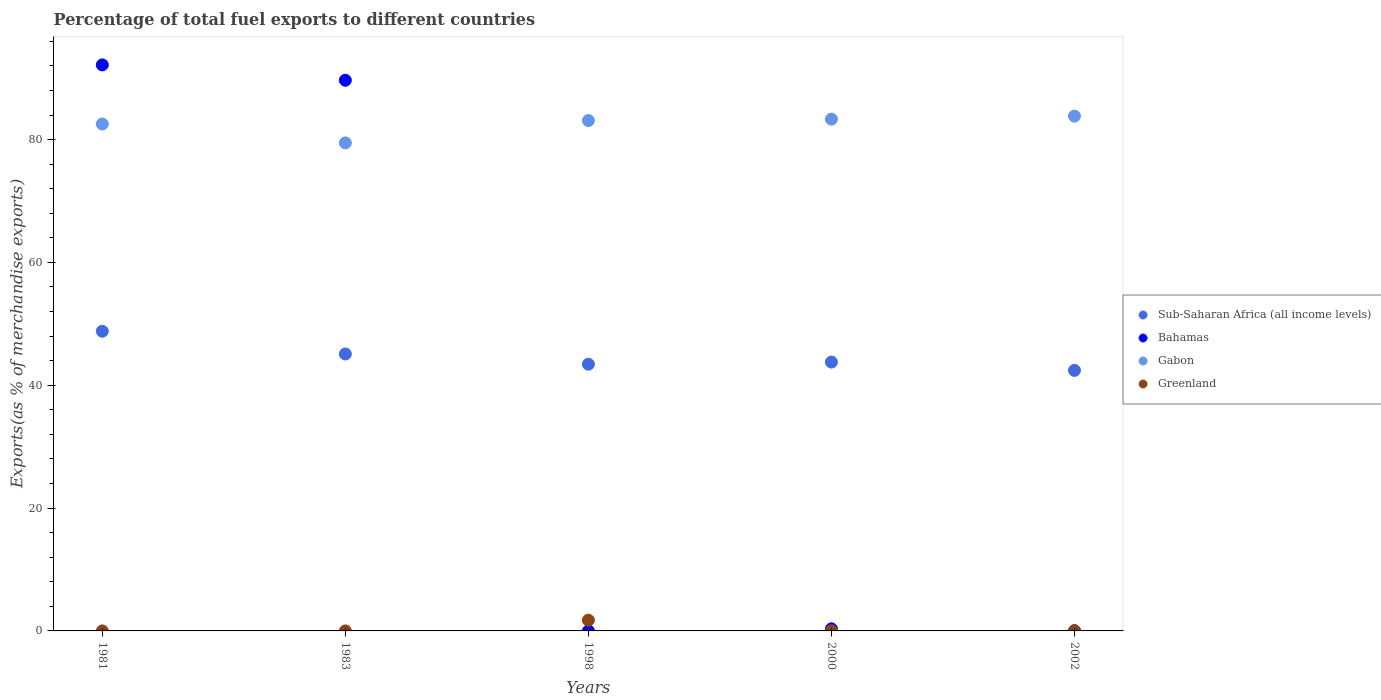Is the number of dotlines equal to the number of legend labels?
Your response must be concise. Yes. What is the percentage of exports to different countries in Sub-Saharan Africa (all income levels) in 1981?
Your answer should be very brief. 48.79. Across all years, what is the maximum percentage of exports to different countries in Bahamas?
Your answer should be very brief. 92.16. Across all years, what is the minimum percentage of exports to different countries in Greenland?
Provide a succinct answer. 1.891174772849889e-5. In which year was the percentage of exports to different countries in Bahamas maximum?
Offer a terse response. 1981. What is the total percentage of exports to different countries in Gabon in the graph?
Provide a short and direct response. 412.24. What is the difference between the percentage of exports to different countries in Sub-Saharan Africa (all income levels) in 1981 and that in 2002?
Offer a terse response. 6.37. What is the difference between the percentage of exports to different countries in Gabon in 2002 and the percentage of exports to different countries in Greenland in 2000?
Provide a succinct answer. 83.79. What is the average percentage of exports to different countries in Bahamas per year?
Provide a short and direct response. 36.44. In the year 2000, what is the difference between the percentage of exports to different countries in Greenland and percentage of exports to different countries in Bahamas?
Your answer should be very brief. -0.31. What is the ratio of the percentage of exports to different countries in Greenland in 1981 to that in 2002?
Offer a terse response. 0.01. What is the difference between the highest and the second highest percentage of exports to different countries in Gabon?
Provide a short and direct response. 0.49. What is the difference between the highest and the lowest percentage of exports to different countries in Gabon?
Offer a terse response. 4.35. Does the percentage of exports to different countries in Greenland monotonically increase over the years?
Provide a succinct answer. No. Is the percentage of exports to different countries in Gabon strictly greater than the percentage of exports to different countries in Greenland over the years?
Offer a very short reply. Yes. How many years are there in the graph?
Keep it short and to the point. 5. What is the difference between two consecutive major ticks on the Y-axis?
Make the answer very short. 20. Are the values on the major ticks of Y-axis written in scientific E-notation?
Provide a succinct answer. No. Does the graph contain grids?
Your answer should be very brief. No. Where does the legend appear in the graph?
Provide a succinct answer. Center right. How many legend labels are there?
Keep it short and to the point. 4. What is the title of the graph?
Offer a terse response. Percentage of total fuel exports to different countries. Does "Slovenia" appear as one of the legend labels in the graph?
Your response must be concise. No. What is the label or title of the Y-axis?
Your answer should be very brief. Exports(as % of merchandise exports). What is the Exports(as % of merchandise exports) of Sub-Saharan Africa (all income levels) in 1981?
Give a very brief answer. 48.79. What is the Exports(as % of merchandise exports) of Bahamas in 1981?
Your response must be concise. 92.16. What is the Exports(as % of merchandise exports) in Gabon in 1981?
Your answer should be compact. 82.53. What is the Exports(as % of merchandise exports) of Greenland in 1981?
Provide a succinct answer. 0. What is the Exports(as % of merchandise exports) in Sub-Saharan Africa (all income levels) in 1983?
Offer a very short reply. 45.09. What is the Exports(as % of merchandise exports) of Bahamas in 1983?
Your response must be concise. 89.66. What is the Exports(as % of merchandise exports) of Gabon in 1983?
Your answer should be very brief. 79.46. What is the Exports(as % of merchandise exports) in Greenland in 1983?
Keep it short and to the point. 1.891174772849889e-5. What is the Exports(as % of merchandise exports) in Sub-Saharan Africa (all income levels) in 1998?
Provide a short and direct response. 43.43. What is the Exports(as % of merchandise exports) in Bahamas in 1998?
Provide a short and direct response. 0. What is the Exports(as % of merchandise exports) of Gabon in 1998?
Your answer should be very brief. 83.1. What is the Exports(as % of merchandise exports) of Greenland in 1998?
Your answer should be compact. 1.75. What is the Exports(as % of merchandise exports) of Sub-Saharan Africa (all income levels) in 2000?
Provide a succinct answer. 43.77. What is the Exports(as % of merchandise exports) of Bahamas in 2000?
Make the answer very short. 0.34. What is the Exports(as % of merchandise exports) in Gabon in 2000?
Give a very brief answer. 83.33. What is the Exports(as % of merchandise exports) of Greenland in 2000?
Give a very brief answer. 0.03. What is the Exports(as % of merchandise exports) of Sub-Saharan Africa (all income levels) in 2002?
Ensure brevity in your answer.  42.42. What is the Exports(as % of merchandise exports) in Bahamas in 2002?
Ensure brevity in your answer.  0.03. What is the Exports(as % of merchandise exports) of Gabon in 2002?
Give a very brief answer. 83.82. What is the Exports(as % of merchandise exports) in Greenland in 2002?
Your answer should be compact. 0.02. Across all years, what is the maximum Exports(as % of merchandise exports) of Sub-Saharan Africa (all income levels)?
Offer a very short reply. 48.79. Across all years, what is the maximum Exports(as % of merchandise exports) of Bahamas?
Offer a terse response. 92.16. Across all years, what is the maximum Exports(as % of merchandise exports) in Gabon?
Your answer should be compact. 83.82. Across all years, what is the maximum Exports(as % of merchandise exports) of Greenland?
Your response must be concise. 1.75. Across all years, what is the minimum Exports(as % of merchandise exports) of Sub-Saharan Africa (all income levels)?
Provide a succinct answer. 42.42. Across all years, what is the minimum Exports(as % of merchandise exports) of Bahamas?
Offer a terse response. 0. Across all years, what is the minimum Exports(as % of merchandise exports) of Gabon?
Your answer should be very brief. 79.46. Across all years, what is the minimum Exports(as % of merchandise exports) of Greenland?
Your answer should be very brief. 1.891174772849889e-5. What is the total Exports(as % of merchandise exports) in Sub-Saharan Africa (all income levels) in the graph?
Ensure brevity in your answer.  223.51. What is the total Exports(as % of merchandise exports) in Bahamas in the graph?
Your response must be concise. 182.19. What is the total Exports(as % of merchandise exports) of Gabon in the graph?
Your answer should be compact. 412.24. What is the total Exports(as % of merchandise exports) in Greenland in the graph?
Provide a succinct answer. 1.8. What is the difference between the Exports(as % of merchandise exports) of Sub-Saharan Africa (all income levels) in 1981 and that in 1983?
Your response must be concise. 3.7. What is the difference between the Exports(as % of merchandise exports) of Bahamas in 1981 and that in 1983?
Your response must be concise. 2.5. What is the difference between the Exports(as % of merchandise exports) of Gabon in 1981 and that in 1983?
Offer a very short reply. 3.07. What is the difference between the Exports(as % of merchandise exports) of Sub-Saharan Africa (all income levels) in 1981 and that in 1998?
Offer a terse response. 5.36. What is the difference between the Exports(as % of merchandise exports) of Bahamas in 1981 and that in 1998?
Ensure brevity in your answer.  92.16. What is the difference between the Exports(as % of merchandise exports) in Gabon in 1981 and that in 1998?
Provide a succinct answer. -0.56. What is the difference between the Exports(as % of merchandise exports) of Greenland in 1981 and that in 1998?
Offer a very short reply. -1.75. What is the difference between the Exports(as % of merchandise exports) of Sub-Saharan Africa (all income levels) in 1981 and that in 2000?
Provide a short and direct response. 5.02. What is the difference between the Exports(as % of merchandise exports) in Bahamas in 1981 and that in 2000?
Your response must be concise. 91.82. What is the difference between the Exports(as % of merchandise exports) of Gabon in 1981 and that in 2000?
Ensure brevity in your answer.  -0.79. What is the difference between the Exports(as % of merchandise exports) of Greenland in 1981 and that in 2000?
Provide a succinct answer. -0.03. What is the difference between the Exports(as % of merchandise exports) in Sub-Saharan Africa (all income levels) in 1981 and that in 2002?
Your answer should be very brief. 6.37. What is the difference between the Exports(as % of merchandise exports) in Bahamas in 1981 and that in 2002?
Offer a terse response. 92.13. What is the difference between the Exports(as % of merchandise exports) in Gabon in 1981 and that in 2002?
Offer a very short reply. -1.28. What is the difference between the Exports(as % of merchandise exports) of Greenland in 1981 and that in 2002?
Make the answer very short. -0.02. What is the difference between the Exports(as % of merchandise exports) of Sub-Saharan Africa (all income levels) in 1983 and that in 1998?
Give a very brief answer. 1.66. What is the difference between the Exports(as % of merchandise exports) in Bahamas in 1983 and that in 1998?
Give a very brief answer. 89.66. What is the difference between the Exports(as % of merchandise exports) in Gabon in 1983 and that in 1998?
Your answer should be very brief. -3.63. What is the difference between the Exports(as % of merchandise exports) in Greenland in 1983 and that in 1998?
Give a very brief answer. -1.75. What is the difference between the Exports(as % of merchandise exports) of Sub-Saharan Africa (all income levels) in 1983 and that in 2000?
Your answer should be very brief. 1.32. What is the difference between the Exports(as % of merchandise exports) in Bahamas in 1983 and that in 2000?
Give a very brief answer. 89.32. What is the difference between the Exports(as % of merchandise exports) of Gabon in 1983 and that in 2000?
Provide a short and direct response. -3.86. What is the difference between the Exports(as % of merchandise exports) in Greenland in 1983 and that in 2000?
Your answer should be compact. -0.03. What is the difference between the Exports(as % of merchandise exports) of Sub-Saharan Africa (all income levels) in 1983 and that in 2002?
Provide a succinct answer. 2.67. What is the difference between the Exports(as % of merchandise exports) of Bahamas in 1983 and that in 2002?
Your answer should be very brief. 89.63. What is the difference between the Exports(as % of merchandise exports) of Gabon in 1983 and that in 2002?
Ensure brevity in your answer.  -4.35. What is the difference between the Exports(as % of merchandise exports) in Greenland in 1983 and that in 2002?
Offer a terse response. -0.02. What is the difference between the Exports(as % of merchandise exports) in Sub-Saharan Africa (all income levels) in 1998 and that in 2000?
Make the answer very short. -0.35. What is the difference between the Exports(as % of merchandise exports) of Bahamas in 1998 and that in 2000?
Your answer should be very brief. -0.34. What is the difference between the Exports(as % of merchandise exports) in Gabon in 1998 and that in 2000?
Offer a very short reply. -0.23. What is the difference between the Exports(as % of merchandise exports) of Greenland in 1998 and that in 2000?
Give a very brief answer. 1.72. What is the difference between the Exports(as % of merchandise exports) of Sub-Saharan Africa (all income levels) in 1998 and that in 2002?
Give a very brief answer. 1.01. What is the difference between the Exports(as % of merchandise exports) in Bahamas in 1998 and that in 2002?
Your response must be concise. -0.03. What is the difference between the Exports(as % of merchandise exports) of Gabon in 1998 and that in 2002?
Offer a very short reply. -0.72. What is the difference between the Exports(as % of merchandise exports) of Greenland in 1998 and that in 2002?
Your response must be concise. 1.73. What is the difference between the Exports(as % of merchandise exports) in Sub-Saharan Africa (all income levels) in 2000 and that in 2002?
Ensure brevity in your answer.  1.35. What is the difference between the Exports(as % of merchandise exports) in Bahamas in 2000 and that in 2002?
Provide a succinct answer. 0.31. What is the difference between the Exports(as % of merchandise exports) in Gabon in 2000 and that in 2002?
Your response must be concise. -0.49. What is the difference between the Exports(as % of merchandise exports) of Greenland in 2000 and that in 2002?
Ensure brevity in your answer.  0. What is the difference between the Exports(as % of merchandise exports) of Sub-Saharan Africa (all income levels) in 1981 and the Exports(as % of merchandise exports) of Bahamas in 1983?
Keep it short and to the point. -40.87. What is the difference between the Exports(as % of merchandise exports) in Sub-Saharan Africa (all income levels) in 1981 and the Exports(as % of merchandise exports) in Gabon in 1983?
Ensure brevity in your answer.  -30.67. What is the difference between the Exports(as % of merchandise exports) in Sub-Saharan Africa (all income levels) in 1981 and the Exports(as % of merchandise exports) in Greenland in 1983?
Offer a terse response. 48.79. What is the difference between the Exports(as % of merchandise exports) of Bahamas in 1981 and the Exports(as % of merchandise exports) of Gabon in 1983?
Offer a terse response. 12.7. What is the difference between the Exports(as % of merchandise exports) in Bahamas in 1981 and the Exports(as % of merchandise exports) in Greenland in 1983?
Provide a succinct answer. 92.16. What is the difference between the Exports(as % of merchandise exports) of Gabon in 1981 and the Exports(as % of merchandise exports) of Greenland in 1983?
Give a very brief answer. 82.53. What is the difference between the Exports(as % of merchandise exports) in Sub-Saharan Africa (all income levels) in 1981 and the Exports(as % of merchandise exports) in Bahamas in 1998?
Ensure brevity in your answer.  48.79. What is the difference between the Exports(as % of merchandise exports) of Sub-Saharan Africa (all income levels) in 1981 and the Exports(as % of merchandise exports) of Gabon in 1998?
Keep it short and to the point. -34.3. What is the difference between the Exports(as % of merchandise exports) in Sub-Saharan Africa (all income levels) in 1981 and the Exports(as % of merchandise exports) in Greenland in 1998?
Your answer should be very brief. 47.04. What is the difference between the Exports(as % of merchandise exports) in Bahamas in 1981 and the Exports(as % of merchandise exports) in Gabon in 1998?
Offer a terse response. 9.07. What is the difference between the Exports(as % of merchandise exports) of Bahamas in 1981 and the Exports(as % of merchandise exports) of Greenland in 1998?
Your answer should be very brief. 90.41. What is the difference between the Exports(as % of merchandise exports) in Gabon in 1981 and the Exports(as % of merchandise exports) in Greenland in 1998?
Your answer should be very brief. 80.78. What is the difference between the Exports(as % of merchandise exports) in Sub-Saharan Africa (all income levels) in 1981 and the Exports(as % of merchandise exports) in Bahamas in 2000?
Offer a terse response. 48.45. What is the difference between the Exports(as % of merchandise exports) in Sub-Saharan Africa (all income levels) in 1981 and the Exports(as % of merchandise exports) in Gabon in 2000?
Give a very brief answer. -34.53. What is the difference between the Exports(as % of merchandise exports) of Sub-Saharan Africa (all income levels) in 1981 and the Exports(as % of merchandise exports) of Greenland in 2000?
Give a very brief answer. 48.76. What is the difference between the Exports(as % of merchandise exports) in Bahamas in 1981 and the Exports(as % of merchandise exports) in Gabon in 2000?
Your response must be concise. 8.84. What is the difference between the Exports(as % of merchandise exports) of Bahamas in 1981 and the Exports(as % of merchandise exports) of Greenland in 2000?
Your answer should be very brief. 92.14. What is the difference between the Exports(as % of merchandise exports) in Gabon in 1981 and the Exports(as % of merchandise exports) in Greenland in 2000?
Give a very brief answer. 82.51. What is the difference between the Exports(as % of merchandise exports) of Sub-Saharan Africa (all income levels) in 1981 and the Exports(as % of merchandise exports) of Bahamas in 2002?
Offer a terse response. 48.76. What is the difference between the Exports(as % of merchandise exports) of Sub-Saharan Africa (all income levels) in 1981 and the Exports(as % of merchandise exports) of Gabon in 2002?
Make the answer very short. -35.03. What is the difference between the Exports(as % of merchandise exports) in Sub-Saharan Africa (all income levels) in 1981 and the Exports(as % of merchandise exports) in Greenland in 2002?
Offer a very short reply. 48.77. What is the difference between the Exports(as % of merchandise exports) of Bahamas in 1981 and the Exports(as % of merchandise exports) of Gabon in 2002?
Your response must be concise. 8.35. What is the difference between the Exports(as % of merchandise exports) in Bahamas in 1981 and the Exports(as % of merchandise exports) in Greenland in 2002?
Your answer should be compact. 92.14. What is the difference between the Exports(as % of merchandise exports) in Gabon in 1981 and the Exports(as % of merchandise exports) in Greenland in 2002?
Keep it short and to the point. 82.51. What is the difference between the Exports(as % of merchandise exports) in Sub-Saharan Africa (all income levels) in 1983 and the Exports(as % of merchandise exports) in Bahamas in 1998?
Make the answer very short. 45.09. What is the difference between the Exports(as % of merchandise exports) of Sub-Saharan Africa (all income levels) in 1983 and the Exports(as % of merchandise exports) of Gabon in 1998?
Your answer should be compact. -38. What is the difference between the Exports(as % of merchandise exports) of Sub-Saharan Africa (all income levels) in 1983 and the Exports(as % of merchandise exports) of Greenland in 1998?
Make the answer very short. 43.34. What is the difference between the Exports(as % of merchandise exports) of Bahamas in 1983 and the Exports(as % of merchandise exports) of Gabon in 1998?
Provide a short and direct response. 6.56. What is the difference between the Exports(as % of merchandise exports) of Bahamas in 1983 and the Exports(as % of merchandise exports) of Greenland in 1998?
Offer a terse response. 87.91. What is the difference between the Exports(as % of merchandise exports) in Gabon in 1983 and the Exports(as % of merchandise exports) in Greenland in 1998?
Provide a succinct answer. 77.71. What is the difference between the Exports(as % of merchandise exports) of Sub-Saharan Africa (all income levels) in 1983 and the Exports(as % of merchandise exports) of Bahamas in 2000?
Your response must be concise. 44.75. What is the difference between the Exports(as % of merchandise exports) in Sub-Saharan Africa (all income levels) in 1983 and the Exports(as % of merchandise exports) in Gabon in 2000?
Keep it short and to the point. -38.23. What is the difference between the Exports(as % of merchandise exports) of Sub-Saharan Africa (all income levels) in 1983 and the Exports(as % of merchandise exports) of Greenland in 2000?
Keep it short and to the point. 45.07. What is the difference between the Exports(as % of merchandise exports) of Bahamas in 1983 and the Exports(as % of merchandise exports) of Gabon in 2000?
Keep it short and to the point. 6.33. What is the difference between the Exports(as % of merchandise exports) of Bahamas in 1983 and the Exports(as % of merchandise exports) of Greenland in 2000?
Make the answer very short. 89.63. What is the difference between the Exports(as % of merchandise exports) in Gabon in 1983 and the Exports(as % of merchandise exports) in Greenland in 2000?
Your answer should be very brief. 79.44. What is the difference between the Exports(as % of merchandise exports) of Sub-Saharan Africa (all income levels) in 1983 and the Exports(as % of merchandise exports) of Bahamas in 2002?
Provide a short and direct response. 45.06. What is the difference between the Exports(as % of merchandise exports) of Sub-Saharan Africa (all income levels) in 1983 and the Exports(as % of merchandise exports) of Gabon in 2002?
Keep it short and to the point. -38.73. What is the difference between the Exports(as % of merchandise exports) of Sub-Saharan Africa (all income levels) in 1983 and the Exports(as % of merchandise exports) of Greenland in 2002?
Your response must be concise. 45.07. What is the difference between the Exports(as % of merchandise exports) of Bahamas in 1983 and the Exports(as % of merchandise exports) of Gabon in 2002?
Provide a short and direct response. 5.84. What is the difference between the Exports(as % of merchandise exports) of Bahamas in 1983 and the Exports(as % of merchandise exports) of Greenland in 2002?
Offer a very short reply. 89.63. What is the difference between the Exports(as % of merchandise exports) in Gabon in 1983 and the Exports(as % of merchandise exports) in Greenland in 2002?
Give a very brief answer. 79.44. What is the difference between the Exports(as % of merchandise exports) in Sub-Saharan Africa (all income levels) in 1998 and the Exports(as % of merchandise exports) in Bahamas in 2000?
Keep it short and to the point. 43.09. What is the difference between the Exports(as % of merchandise exports) of Sub-Saharan Africa (all income levels) in 1998 and the Exports(as % of merchandise exports) of Gabon in 2000?
Provide a succinct answer. -39.9. What is the difference between the Exports(as % of merchandise exports) in Sub-Saharan Africa (all income levels) in 1998 and the Exports(as % of merchandise exports) in Greenland in 2000?
Offer a terse response. 43.4. What is the difference between the Exports(as % of merchandise exports) in Bahamas in 1998 and the Exports(as % of merchandise exports) in Gabon in 2000?
Give a very brief answer. -83.33. What is the difference between the Exports(as % of merchandise exports) of Bahamas in 1998 and the Exports(as % of merchandise exports) of Greenland in 2000?
Provide a succinct answer. -0.03. What is the difference between the Exports(as % of merchandise exports) in Gabon in 1998 and the Exports(as % of merchandise exports) in Greenland in 2000?
Ensure brevity in your answer.  83.07. What is the difference between the Exports(as % of merchandise exports) of Sub-Saharan Africa (all income levels) in 1998 and the Exports(as % of merchandise exports) of Bahamas in 2002?
Ensure brevity in your answer.  43.4. What is the difference between the Exports(as % of merchandise exports) in Sub-Saharan Africa (all income levels) in 1998 and the Exports(as % of merchandise exports) in Gabon in 2002?
Give a very brief answer. -40.39. What is the difference between the Exports(as % of merchandise exports) of Sub-Saharan Africa (all income levels) in 1998 and the Exports(as % of merchandise exports) of Greenland in 2002?
Your answer should be very brief. 43.4. What is the difference between the Exports(as % of merchandise exports) of Bahamas in 1998 and the Exports(as % of merchandise exports) of Gabon in 2002?
Provide a succinct answer. -83.82. What is the difference between the Exports(as % of merchandise exports) in Bahamas in 1998 and the Exports(as % of merchandise exports) in Greenland in 2002?
Give a very brief answer. -0.02. What is the difference between the Exports(as % of merchandise exports) of Gabon in 1998 and the Exports(as % of merchandise exports) of Greenland in 2002?
Keep it short and to the point. 83.07. What is the difference between the Exports(as % of merchandise exports) in Sub-Saharan Africa (all income levels) in 2000 and the Exports(as % of merchandise exports) in Bahamas in 2002?
Ensure brevity in your answer.  43.74. What is the difference between the Exports(as % of merchandise exports) of Sub-Saharan Africa (all income levels) in 2000 and the Exports(as % of merchandise exports) of Gabon in 2002?
Ensure brevity in your answer.  -40.04. What is the difference between the Exports(as % of merchandise exports) of Sub-Saharan Africa (all income levels) in 2000 and the Exports(as % of merchandise exports) of Greenland in 2002?
Offer a very short reply. 43.75. What is the difference between the Exports(as % of merchandise exports) in Bahamas in 2000 and the Exports(as % of merchandise exports) in Gabon in 2002?
Your answer should be very brief. -83.48. What is the difference between the Exports(as % of merchandise exports) of Bahamas in 2000 and the Exports(as % of merchandise exports) of Greenland in 2002?
Ensure brevity in your answer.  0.32. What is the difference between the Exports(as % of merchandise exports) of Gabon in 2000 and the Exports(as % of merchandise exports) of Greenland in 2002?
Your answer should be compact. 83.3. What is the average Exports(as % of merchandise exports) in Sub-Saharan Africa (all income levels) per year?
Provide a succinct answer. 44.7. What is the average Exports(as % of merchandise exports) in Bahamas per year?
Make the answer very short. 36.44. What is the average Exports(as % of merchandise exports) of Gabon per year?
Provide a succinct answer. 82.45. What is the average Exports(as % of merchandise exports) of Greenland per year?
Offer a very short reply. 0.36. In the year 1981, what is the difference between the Exports(as % of merchandise exports) in Sub-Saharan Africa (all income levels) and Exports(as % of merchandise exports) in Bahamas?
Keep it short and to the point. -43.37. In the year 1981, what is the difference between the Exports(as % of merchandise exports) in Sub-Saharan Africa (all income levels) and Exports(as % of merchandise exports) in Gabon?
Offer a terse response. -33.74. In the year 1981, what is the difference between the Exports(as % of merchandise exports) of Sub-Saharan Africa (all income levels) and Exports(as % of merchandise exports) of Greenland?
Ensure brevity in your answer.  48.79. In the year 1981, what is the difference between the Exports(as % of merchandise exports) in Bahamas and Exports(as % of merchandise exports) in Gabon?
Keep it short and to the point. 9.63. In the year 1981, what is the difference between the Exports(as % of merchandise exports) of Bahamas and Exports(as % of merchandise exports) of Greenland?
Your answer should be very brief. 92.16. In the year 1981, what is the difference between the Exports(as % of merchandise exports) of Gabon and Exports(as % of merchandise exports) of Greenland?
Provide a short and direct response. 82.53. In the year 1983, what is the difference between the Exports(as % of merchandise exports) in Sub-Saharan Africa (all income levels) and Exports(as % of merchandise exports) in Bahamas?
Offer a very short reply. -44.57. In the year 1983, what is the difference between the Exports(as % of merchandise exports) of Sub-Saharan Africa (all income levels) and Exports(as % of merchandise exports) of Gabon?
Keep it short and to the point. -34.37. In the year 1983, what is the difference between the Exports(as % of merchandise exports) in Sub-Saharan Africa (all income levels) and Exports(as % of merchandise exports) in Greenland?
Your response must be concise. 45.09. In the year 1983, what is the difference between the Exports(as % of merchandise exports) in Bahamas and Exports(as % of merchandise exports) in Gabon?
Your answer should be very brief. 10.2. In the year 1983, what is the difference between the Exports(as % of merchandise exports) in Bahamas and Exports(as % of merchandise exports) in Greenland?
Provide a succinct answer. 89.66. In the year 1983, what is the difference between the Exports(as % of merchandise exports) in Gabon and Exports(as % of merchandise exports) in Greenland?
Provide a succinct answer. 79.46. In the year 1998, what is the difference between the Exports(as % of merchandise exports) of Sub-Saharan Africa (all income levels) and Exports(as % of merchandise exports) of Bahamas?
Offer a very short reply. 43.43. In the year 1998, what is the difference between the Exports(as % of merchandise exports) of Sub-Saharan Africa (all income levels) and Exports(as % of merchandise exports) of Gabon?
Provide a succinct answer. -39.67. In the year 1998, what is the difference between the Exports(as % of merchandise exports) of Sub-Saharan Africa (all income levels) and Exports(as % of merchandise exports) of Greenland?
Offer a very short reply. 41.68. In the year 1998, what is the difference between the Exports(as % of merchandise exports) of Bahamas and Exports(as % of merchandise exports) of Gabon?
Provide a short and direct response. -83.09. In the year 1998, what is the difference between the Exports(as % of merchandise exports) of Bahamas and Exports(as % of merchandise exports) of Greenland?
Your answer should be compact. -1.75. In the year 1998, what is the difference between the Exports(as % of merchandise exports) in Gabon and Exports(as % of merchandise exports) in Greenland?
Provide a succinct answer. 81.34. In the year 2000, what is the difference between the Exports(as % of merchandise exports) of Sub-Saharan Africa (all income levels) and Exports(as % of merchandise exports) of Bahamas?
Keep it short and to the point. 43.43. In the year 2000, what is the difference between the Exports(as % of merchandise exports) of Sub-Saharan Africa (all income levels) and Exports(as % of merchandise exports) of Gabon?
Your answer should be very brief. -39.55. In the year 2000, what is the difference between the Exports(as % of merchandise exports) in Sub-Saharan Africa (all income levels) and Exports(as % of merchandise exports) in Greenland?
Offer a very short reply. 43.75. In the year 2000, what is the difference between the Exports(as % of merchandise exports) in Bahamas and Exports(as % of merchandise exports) in Gabon?
Offer a terse response. -82.98. In the year 2000, what is the difference between the Exports(as % of merchandise exports) in Bahamas and Exports(as % of merchandise exports) in Greenland?
Your answer should be very brief. 0.31. In the year 2000, what is the difference between the Exports(as % of merchandise exports) in Gabon and Exports(as % of merchandise exports) in Greenland?
Provide a succinct answer. 83.3. In the year 2002, what is the difference between the Exports(as % of merchandise exports) in Sub-Saharan Africa (all income levels) and Exports(as % of merchandise exports) in Bahamas?
Make the answer very short. 42.39. In the year 2002, what is the difference between the Exports(as % of merchandise exports) in Sub-Saharan Africa (all income levels) and Exports(as % of merchandise exports) in Gabon?
Offer a very short reply. -41.4. In the year 2002, what is the difference between the Exports(as % of merchandise exports) of Sub-Saharan Africa (all income levels) and Exports(as % of merchandise exports) of Greenland?
Your answer should be very brief. 42.4. In the year 2002, what is the difference between the Exports(as % of merchandise exports) in Bahamas and Exports(as % of merchandise exports) in Gabon?
Offer a very short reply. -83.79. In the year 2002, what is the difference between the Exports(as % of merchandise exports) in Bahamas and Exports(as % of merchandise exports) in Greenland?
Your answer should be compact. 0. In the year 2002, what is the difference between the Exports(as % of merchandise exports) of Gabon and Exports(as % of merchandise exports) of Greenland?
Provide a short and direct response. 83.79. What is the ratio of the Exports(as % of merchandise exports) of Sub-Saharan Africa (all income levels) in 1981 to that in 1983?
Your answer should be compact. 1.08. What is the ratio of the Exports(as % of merchandise exports) of Bahamas in 1981 to that in 1983?
Provide a succinct answer. 1.03. What is the ratio of the Exports(as % of merchandise exports) of Gabon in 1981 to that in 1983?
Give a very brief answer. 1.04. What is the ratio of the Exports(as % of merchandise exports) of Greenland in 1981 to that in 1983?
Your answer should be very brief. 16.11. What is the ratio of the Exports(as % of merchandise exports) of Sub-Saharan Africa (all income levels) in 1981 to that in 1998?
Offer a terse response. 1.12. What is the ratio of the Exports(as % of merchandise exports) of Bahamas in 1981 to that in 1998?
Your answer should be compact. 1.93e+05. What is the ratio of the Exports(as % of merchandise exports) of Gabon in 1981 to that in 1998?
Keep it short and to the point. 0.99. What is the ratio of the Exports(as % of merchandise exports) in Sub-Saharan Africa (all income levels) in 1981 to that in 2000?
Offer a terse response. 1.11. What is the ratio of the Exports(as % of merchandise exports) of Bahamas in 1981 to that in 2000?
Make the answer very short. 269.9. What is the ratio of the Exports(as % of merchandise exports) of Greenland in 1981 to that in 2000?
Ensure brevity in your answer.  0.01. What is the ratio of the Exports(as % of merchandise exports) of Sub-Saharan Africa (all income levels) in 1981 to that in 2002?
Make the answer very short. 1.15. What is the ratio of the Exports(as % of merchandise exports) in Bahamas in 1981 to that in 2002?
Provide a short and direct response. 3209.23. What is the ratio of the Exports(as % of merchandise exports) of Gabon in 1981 to that in 2002?
Offer a very short reply. 0.98. What is the ratio of the Exports(as % of merchandise exports) of Greenland in 1981 to that in 2002?
Ensure brevity in your answer.  0.01. What is the ratio of the Exports(as % of merchandise exports) in Sub-Saharan Africa (all income levels) in 1983 to that in 1998?
Ensure brevity in your answer.  1.04. What is the ratio of the Exports(as % of merchandise exports) in Bahamas in 1983 to that in 1998?
Your answer should be very brief. 1.88e+05. What is the ratio of the Exports(as % of merchandise exports) in Gabon in 1983 to that in 1998?
Make the answer very short. 0.96. What is the ratio of the Exports(as % of merchandise exports) of Sub-Saharan Africa (all income levels) in 1983 to that in 2000?
Offer a very short reply. 1.03. What is the ratio of the Exports(as % of merchandise exports) of Bahamas in 1983 to that in 2000?
Your answer should be compact. 262.57. What is the ratio of the Exports(as % of merchandise exports) of Gabon in 1983 to that in 2000?
Keep it short and to the point. 0.95. What is the ratio of the Exports(as % of merchandise exports) in Greenland in 1983 to that in 2000?
Give a very brief answer. 0. What is the ratio of the Exports(as % of merchandise exports) in Sub-Saharan Africa (all income levels) in 1983 to that in 2002?
Offer a very short reply. 1.06. What is the ratio of the Exports(as % of merchandise exports) of Bahamas in 1983 to that in 2002?
Your response must be concise. 3122.01. What is the ratio of the Exports(as % of merchandise exports) of Gabon in 1983 to that in 2002?
Provide a succinct answer. 0.95. What is the ratio of the Exports(as % of merchandise exports) in Greenland in 1983 to that in 2002?
Provide a succinct answer. 0. What is the ratio of the Exports(as % of merchandise exports) in Sub-Saharan Africa (all income levels) in 1998 to that in 2000?
Offer a very short reply. 0.99. What is the ratio of the Exports(as % of merchandise exports) of Bahamas in 1998 to that in 2000?
Give a very brief answer. 0. What is the ratio of the Exports(as % of merchandise exports) in Greenland in 1998 to that in 2000?
Your answer should be compact. 64.63. What is the ratio of the Exports(as % of merchandise exports) of Sub-Saharan Africa (all income levels) in 1998 to that in 2002?
Provide a succinct answer. 1.02. What is the ratio of the Exports(as % of merchandise exports) of Bahamas in 1998 to that in 2002?
Offer a terse response. 0.02. What is the ratio of the Exports(as % of merchandise exports) in Gabon in 1998 to that in 2002?
Ensure brevity in your answer.  0.99. What is the ratio of the Exports(as % of merchandise exports) in Greenland in 1998 to that in 2002?
Keep it short and to the point. 70.16. What is the ratio of the Exports(as % of merchandise exports) of Sub-Saharan Africa (all income levels) in 2000 to that in 2002?
Give a very brief answer. 1.03. What is the ratio of the Exports(as % of merchandise exports) in Bahamas in 2000 to that in 2002?
Ensure brevity in your answer.  11.89. What is the ratio of the Exports(as % of merchandise exports) of Gabon in 2000 to that in 2002?
Keep it short and to the point. 0.99. What is the ratio of the Exports(as % of merchandise exports) in Greenland in 2000 to that in 2002?
Your response must be concise. 1.09. What is the difference between the highest and the second highest Exports(as % of merchandise exports) of Sub-Saharan Africa (all income levels)?
Give a very brief answer. 3.7. What is the difference between the highest and the second highest Exports(as % of merchandise exports) in Bahamas?
Ensure brevity in your answer.  2.5. What is the difference between the highest and the second highest Exports(as % of merchandise exports) of Gabon?
Offer a very short reply. 0.49. What is the difference between the highest and the second highest Exports(as % of merchandise exports) in Greenland?
Ensure brevity in your answer.  1.72. What is the difference between the highest and the lowest Exports(as % of merchandise exports) of Sub-Saharan Africa (all income levels)?
Your answer should be very brief. 6.37. What is the difference between the highest and the lowest Exports(as % of merchandise exports) in Bahamas?
Ensure brevity in your answer.  92.16. What is the difference between the highest and the lowest Exports(as % of merchandise exports) in Gabon?
Your response must be concise. 4.35. What is the difference between the highest and the lowest Exports(as % of merchandise exports) of Greenland?
Keep it short and to the point. 1.75. 